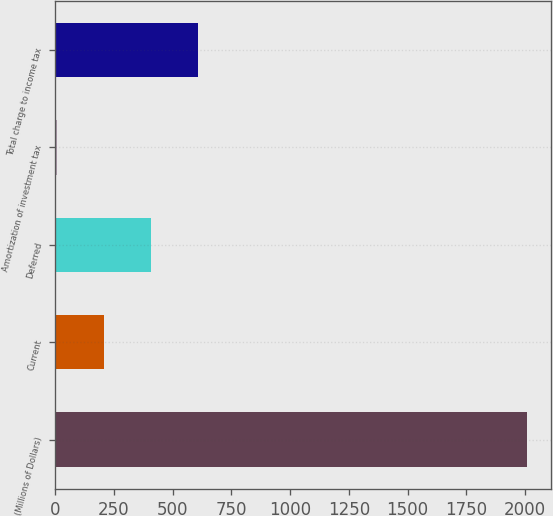Convert chart to OTSL. <chart><loc_0><loc_0><loc_500><loc_500><bar_chart><fcel>(Millions of Dollars)<fcel>Current<fcel>Deferred<fcel>Amortization of investment tax<fcel>Total charge to income tax<nl><fcel>2010<fcel>206.4<fcel>406.8<fcel>6<fcel>607.2<nl></chart> 